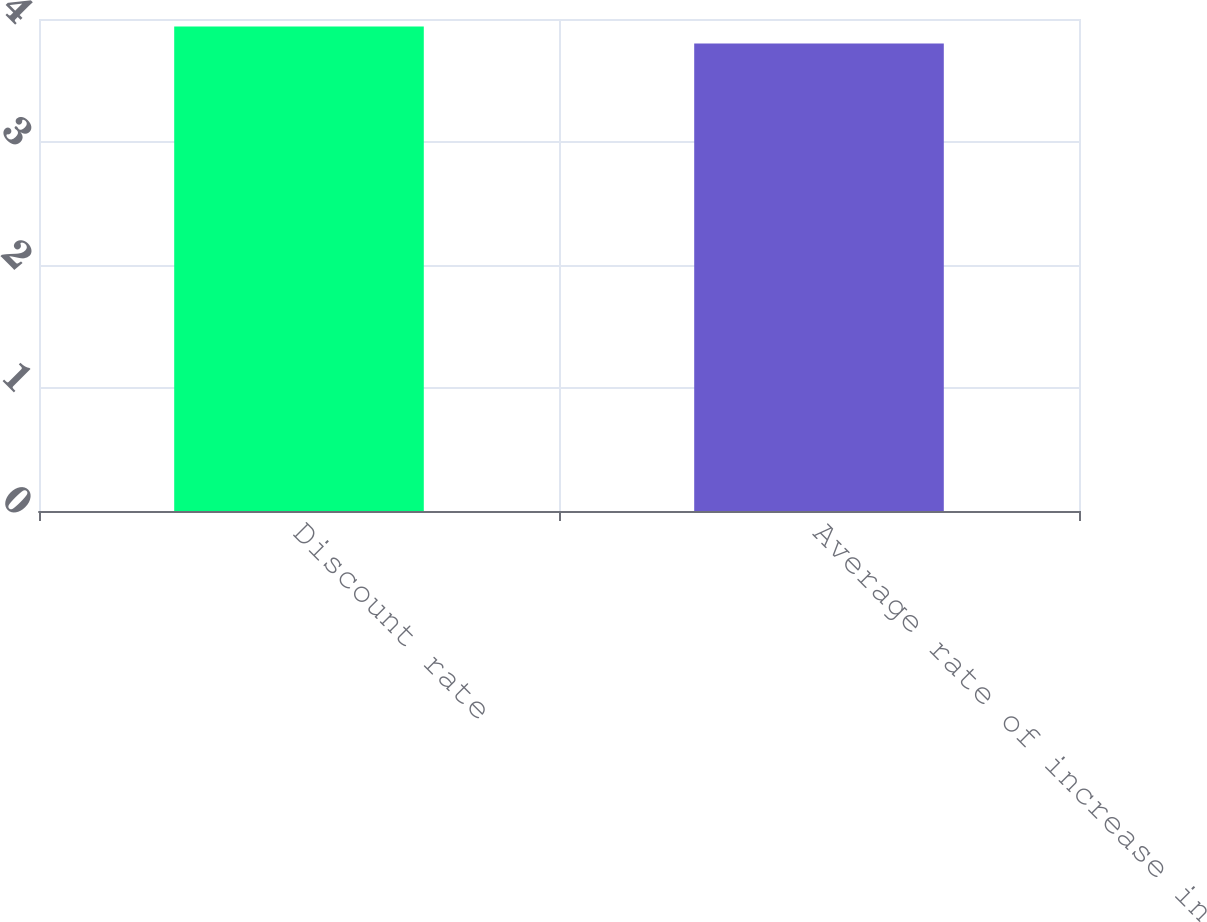<chart> <loc_0><loc_0><loc_500><loc_500><bar_chart><fcel>Discount rate<fcel>Average rate of increase in<nl><fcel>3.94<fcel>3.8<nl></chart> 